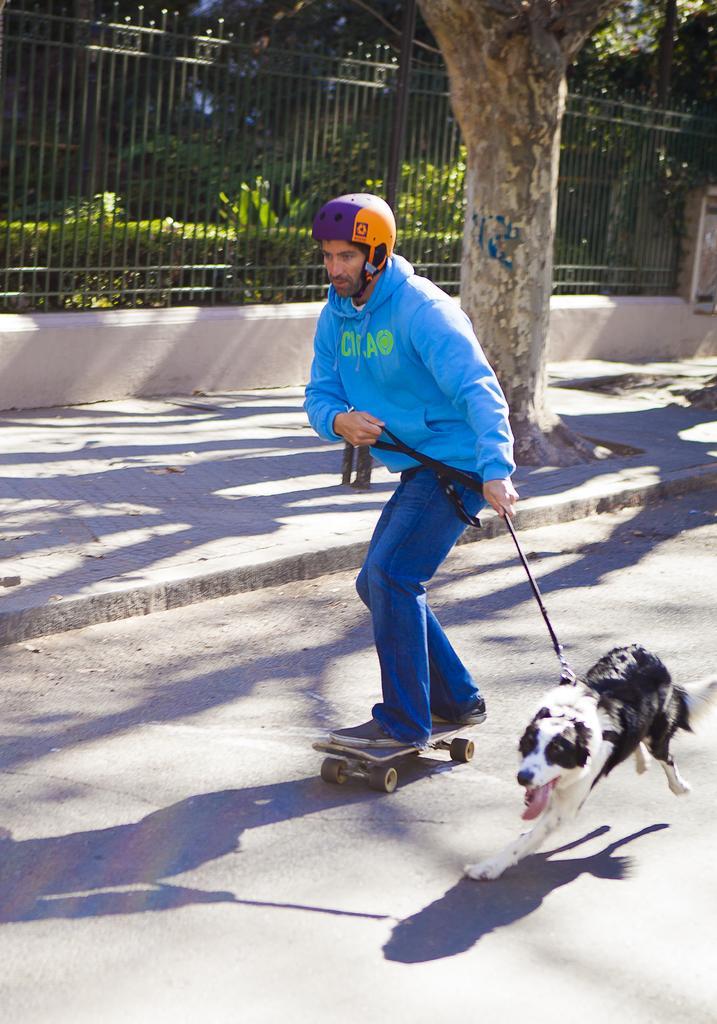Describe this image in one or two sentences. In the center of the image we can see person skating on the road holding a dog. In the background we can see tree, fencing, plants and grass. 